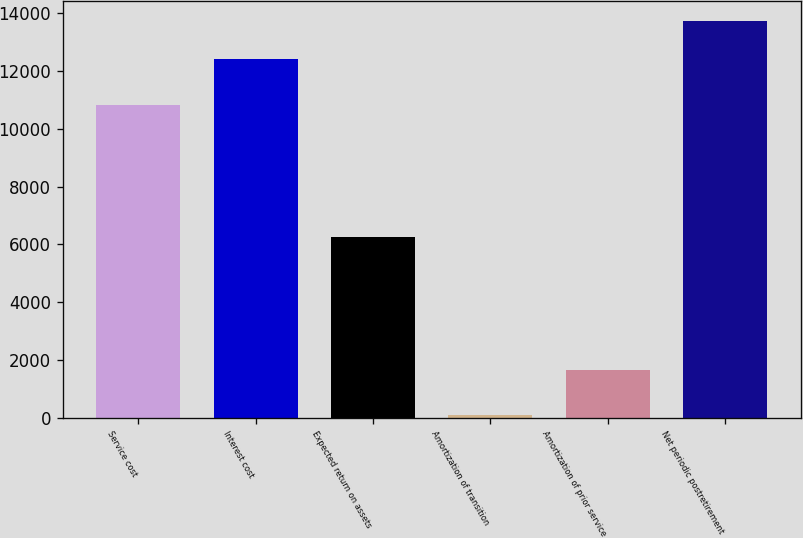<chart> <loc_0><loc_0><loc_500><loc_500><bar_chart><fcel>Service cost<fcel>Interest cost<fcel>Expected return on assets<fcel>Amortization of transition<fcel>Amortization of prior service<fcel>Net periodic postretirement<nl><fcel>10823<fcel>12424<fcel>6264<fcel>82<fcel>1644<fcel>13741.2<nl></chart> 